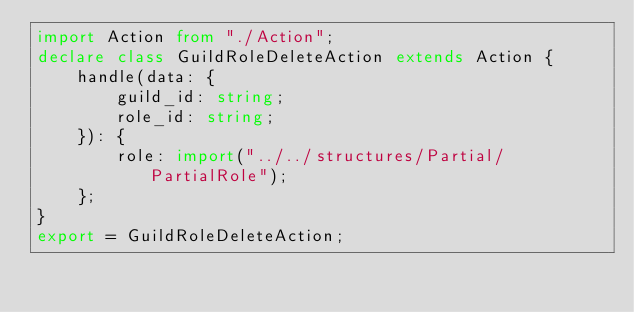<code> <loc_0><loc_0><loc_500><loc_500><_TypeScript_>import Action from "./Action";
declare class GuildRoleDeleteAction extends Action {
    handle(data: {
        guild_id: string;
        role_id: string;
    }): {
        role: import("../../structures/Partial/PartialRole");
    };
}
export = GuildRoleDeleteAction;
</code> 